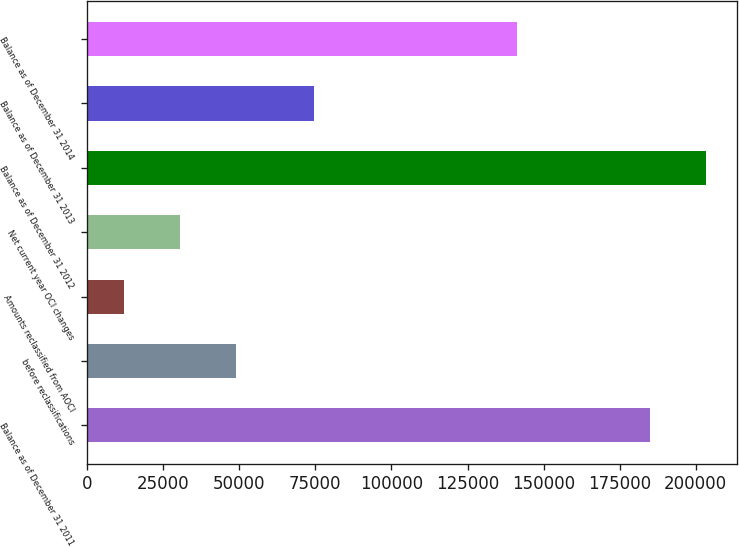Convert chart to OTSL. <chart><loc_0><loc_0><loc_500><loc_500><bar_chart><fcel>Balance as of December 31 2011<fcel>before reclassifications<fcel>Amounts reclassified from AOCI<fcel>Net current year OCI changes<fcel>Balance as of December 31 2012<fcel>Balance as of December 31 2013<fcel>Balance as of December 31 2014<nl><fcel>184858<fcel>49041.4<fcel>11965<fcel>30503.2<fcel>203396<fcel>74453<fcel>141392<nl></chart> 